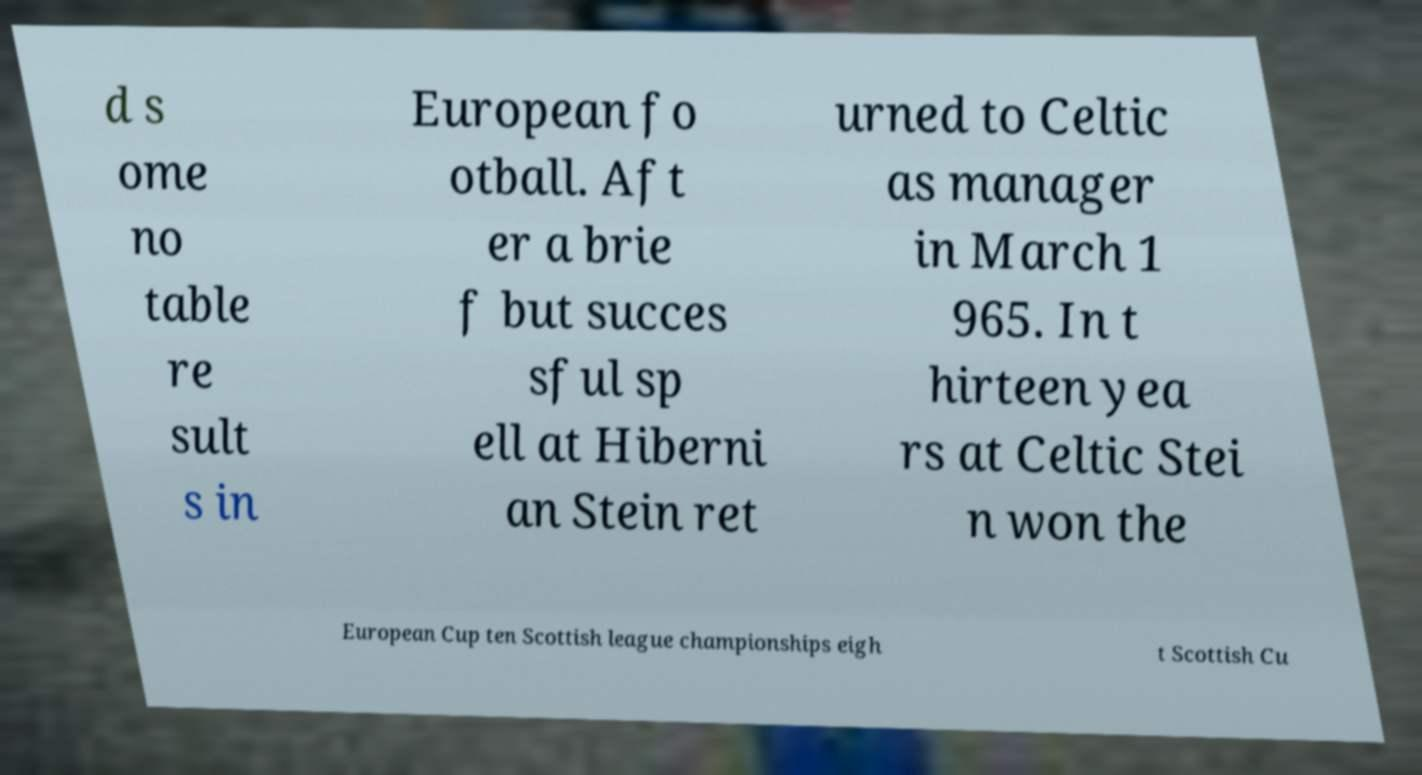Can you read and provide the text displayed in the image?This photo seems to have some interesting text. Can you extract and type it out for me? d s ome no table re sult s in European fo otball. Aft er a brie f but succes sful sp ell at Hiberni an Stein ret urned to Celtic as manager in March 1 965. In t hirteen yea rs at Celtic Stei n won the European Cup ten Scottish league championships eigh t Scottish Cu 